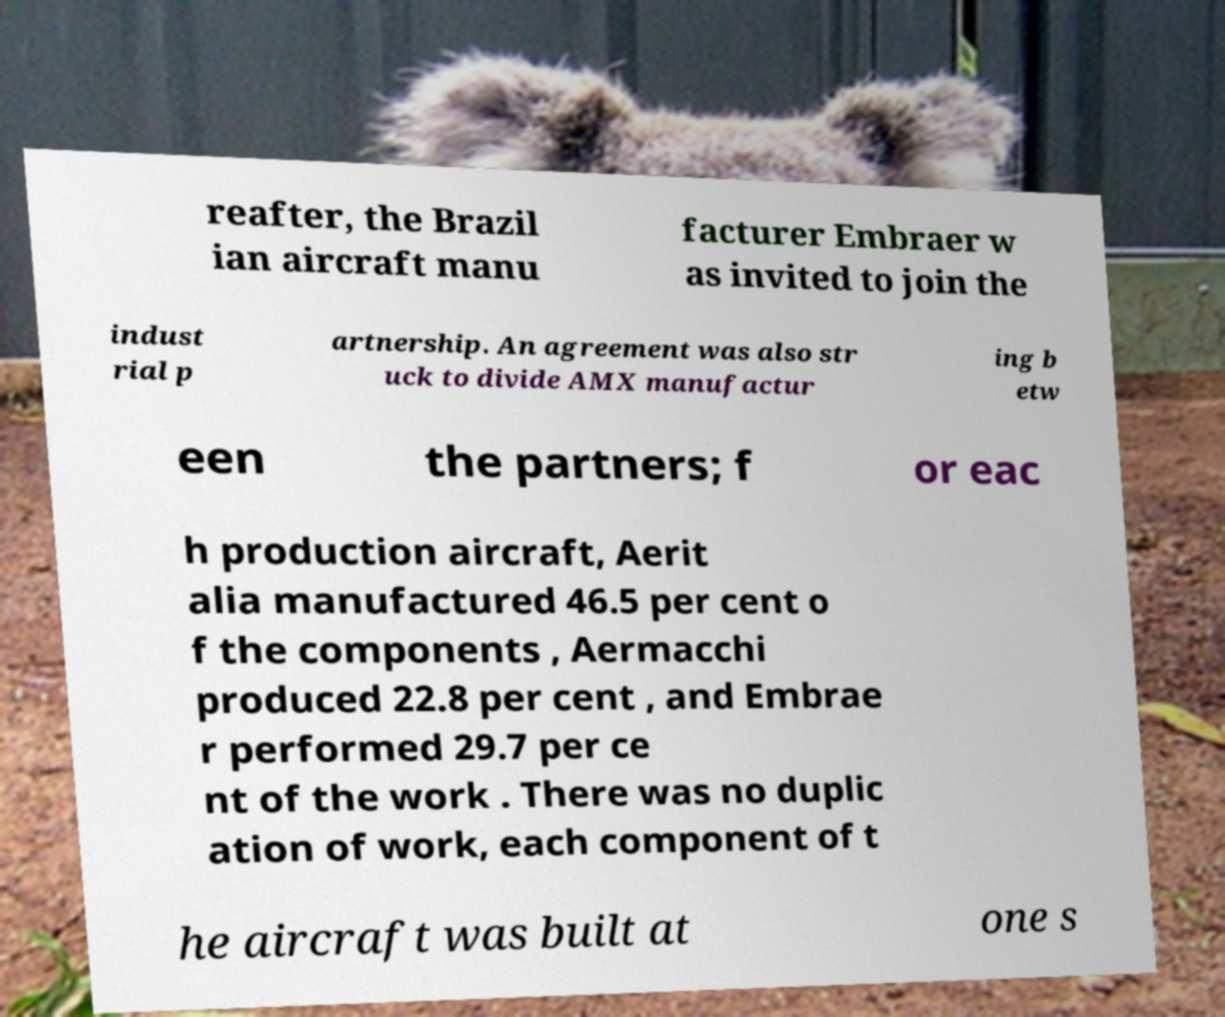For documentation purposes, I need the text within this image transcribed. Could you provide that? reafter, the Brazil ian aircraft manu facturer Embraer w as invited to join the indust rial p artnership. An agreement was also str uck to divide AMX manufactur ing b etw een the partners; f or eac h production aircraft, Aerit alia manufactured 46.5 per cent o f the components , Aermacchi produced 22.8 per cent , and Embrae r performed 29.7 per ce nt of the work . There was no duplic ation of work, each component of t he aircraft was built at one s 